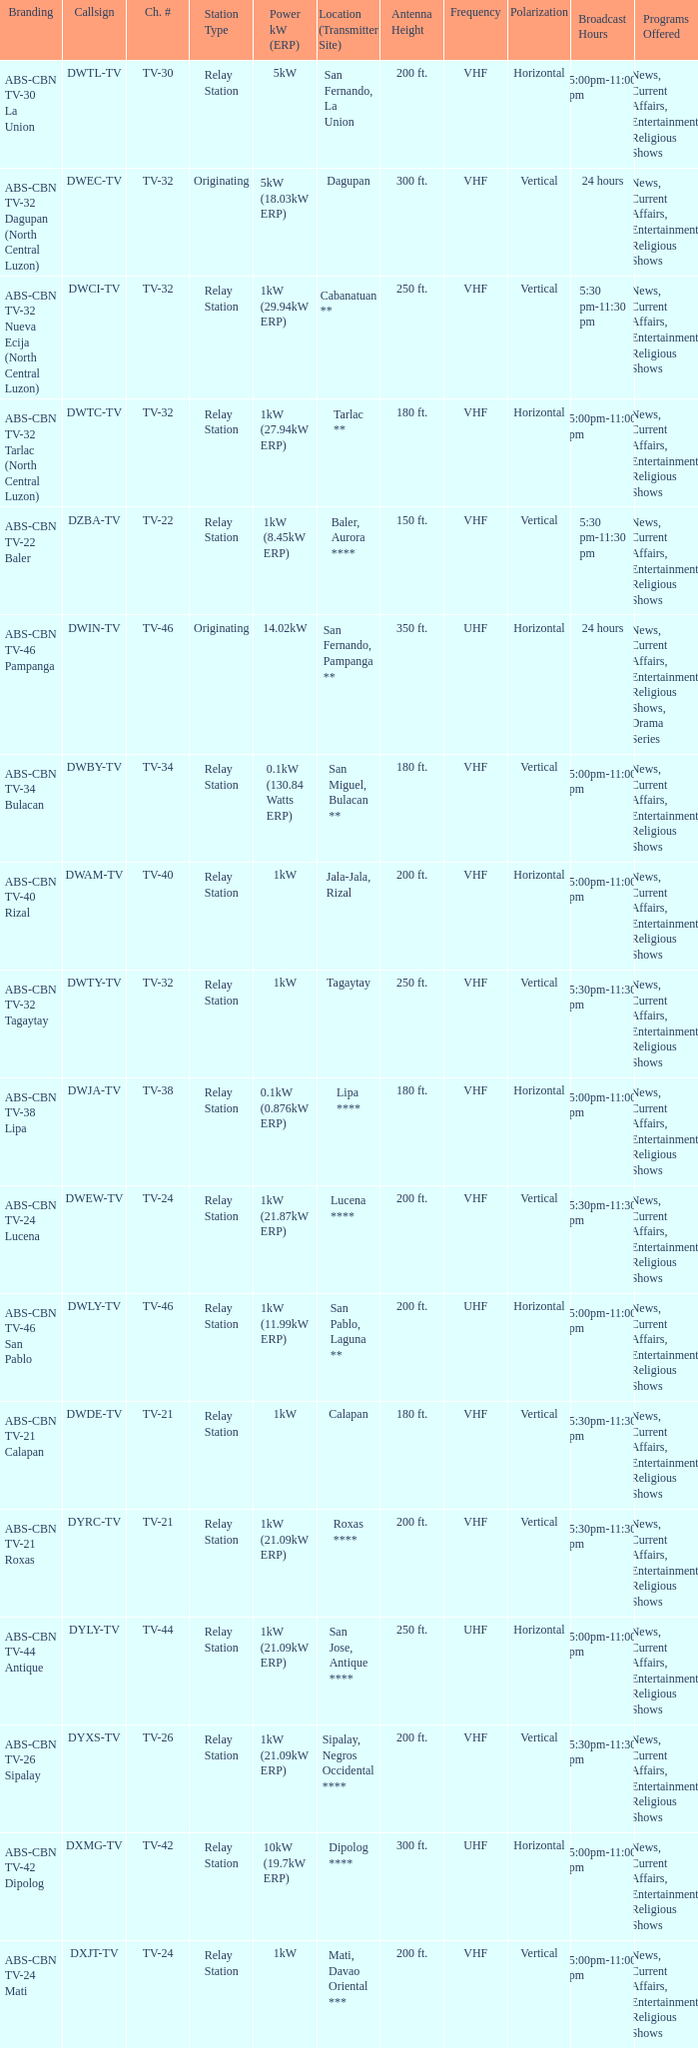How many brandings are there where the Power kW (ERP) is 1kW (29.94kW ERP)? 1.0. 